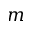Convert formula to latex. <formula><loc_0><loc_0><loc_500><loc_500>m</formula> 